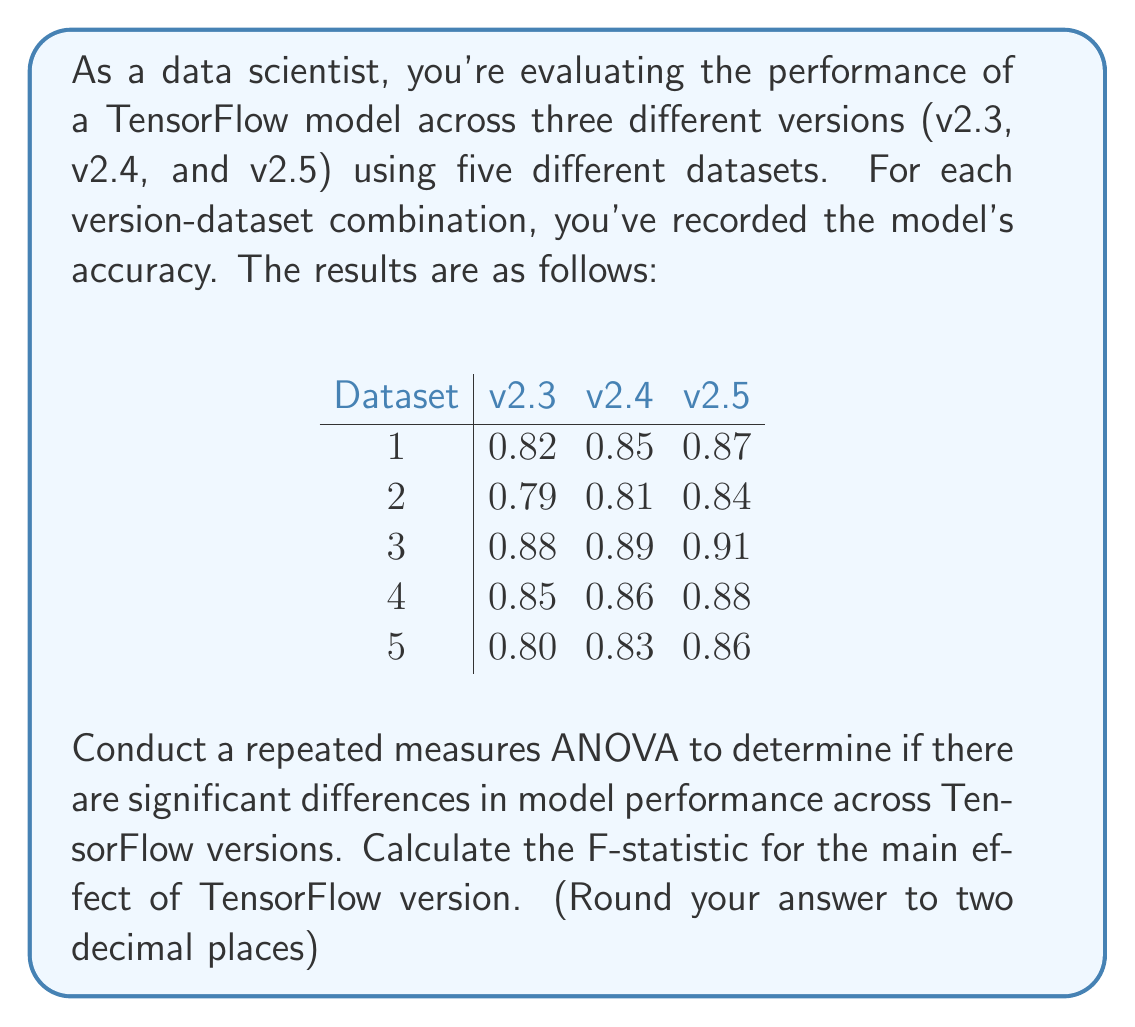Can you answer this question? To conduct a repeated measures ANOVA and calculate the F-statistic, we'll follow these steps:

1. Calculate the means for each condition (TensorFlow version):
   $$\bar{X}_{v2.3} = 0.828, \bar{X}_{v2.4} = 0.848, \bar{X}_{v2.5} = 0.872$$

2. Calculate the grand mean:
   $$\bar{X}_{grand} = \frac{0.828 + 0.848 + 0.872}{3} = 0.849$$

3. Calculate SS_between (Sum of Squares between conditions):
   $$SS_{between} = n\sum_{i=1}^k (\bar{X}_i - \bar{X}_{grand})^2$$
   $$SS_{between} = 5[(0.828 - 0.849)^2 + (0.848 - 0.849)^2 + (0.872 - 0.849)^2]$$
   $$SS_{between} = 5(0.000441 + 0.000001 + 0.000529) = 0.004855$$

4. Calculate SS_total (Total Sum of Squares):
   $$SS_{total} = \sum_{i=1}^k \sum_{j=1}^n (X_{ij} - \bar{X}_{grand})^2 = 0.0202$$

5. Calculate SS_within (Sum of Squares within conditions):
   $$SS_{within} = SS_{total} - SS_{between} = 0.0202 - 0.004855 = 0.015345$$

6. Calculate degrees of freedom:
   $$df_{between} = k - 1 = 3 - 1 = 2$$
   $$df_{within} = k(n - 1) = 3(5 - 1) = 12$$

7. Calculate Mean Squares:
   $$MS_{between} = \frac{SS_{between}}{df_{between}} = \frac{0.004855}{2} = 0.0024275$$
   $$MS_{within} = \frac{SS_{within}}{df_{within}} = \frac{0.015345}{12} = 0.00127875$$

8. Calculate F-statistic:
   $$F = \frac{MS_{between}}{MS_{within}} = \frac{0.0024275}{0.00127875} = 1.8984$$

Rounding to two decimal places, we get F = 1.90.
Answer: 1.90 